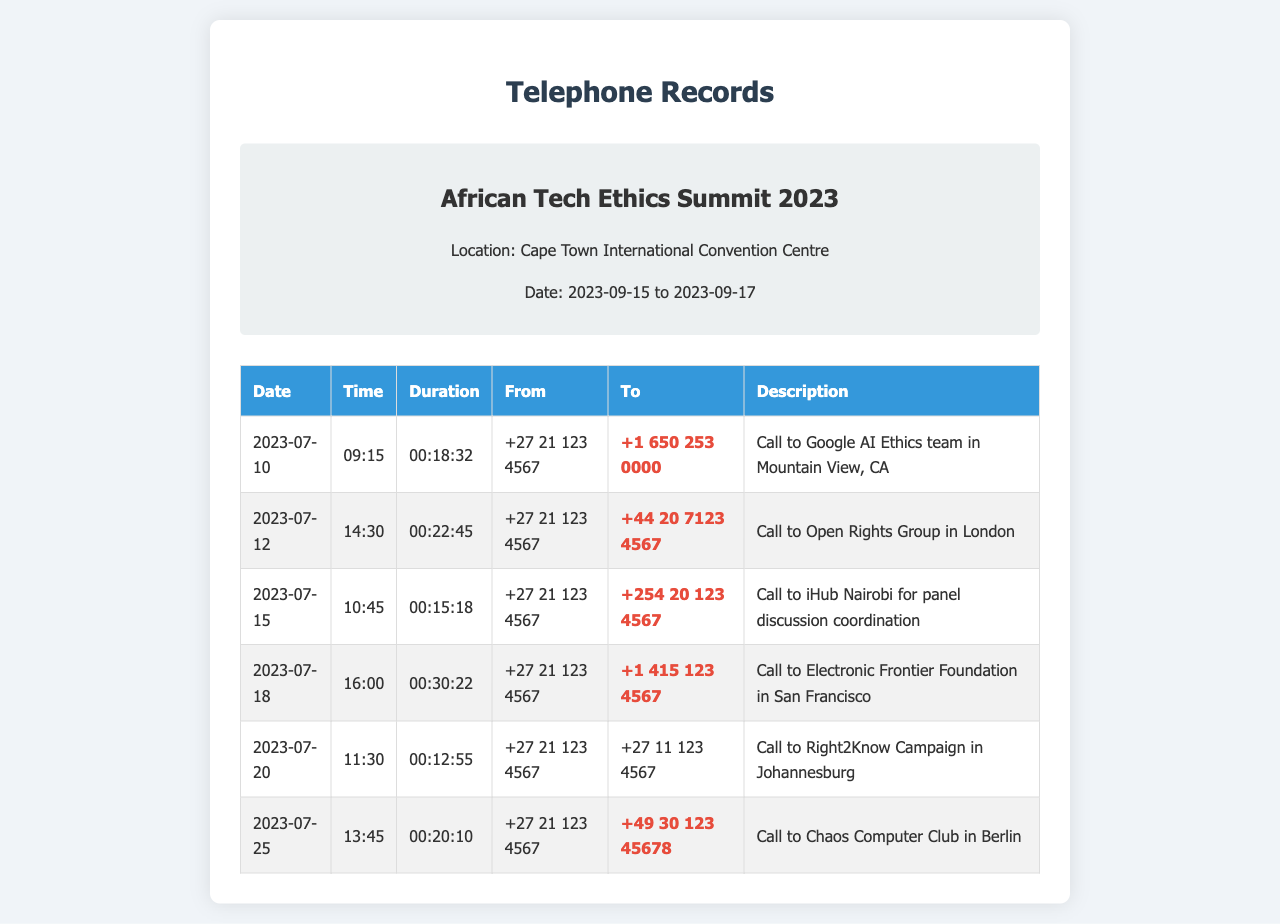what is the venue of the conference? The document states that the conference is held at the Cape Town International Convention Centre.
Answer: Cape Town International Convention Centre when did the conference take place? The conference dates are provided in the document, which are from September 15 to September 17, 2023.
Answer: 2023-09-15 to 2023-09-17 who did the call on 2023-07-12 connect to? The call made on this date is mentioned in the document, which connected to the Open Rights Group in London.
Answer: Open Rights Group how long was the call to the Electronic Frontier Foundation? The document specifies the duration of the call to Electronic Frontier Foundation as 00:30:22.
Answer: 00:30:22 how many international calls are listed in the log? By reviewing the table in the document, we can count the number of international call logs present.
Answer: 5 which organization based in Nairobi was called? The document describes a call to iHub Nairobi for panel discussion coordination.
Answer: iHub Nairobi what is the telephone number of the caller from Cape Town? The document provides the caller's number, which is +27 21 123 4567.
Answer: +27 21 123 4567 which city is the Chaos Computer Club located in? According to the document, the Chaos Computer Club is located in Berlin.
Answer: Berlin 